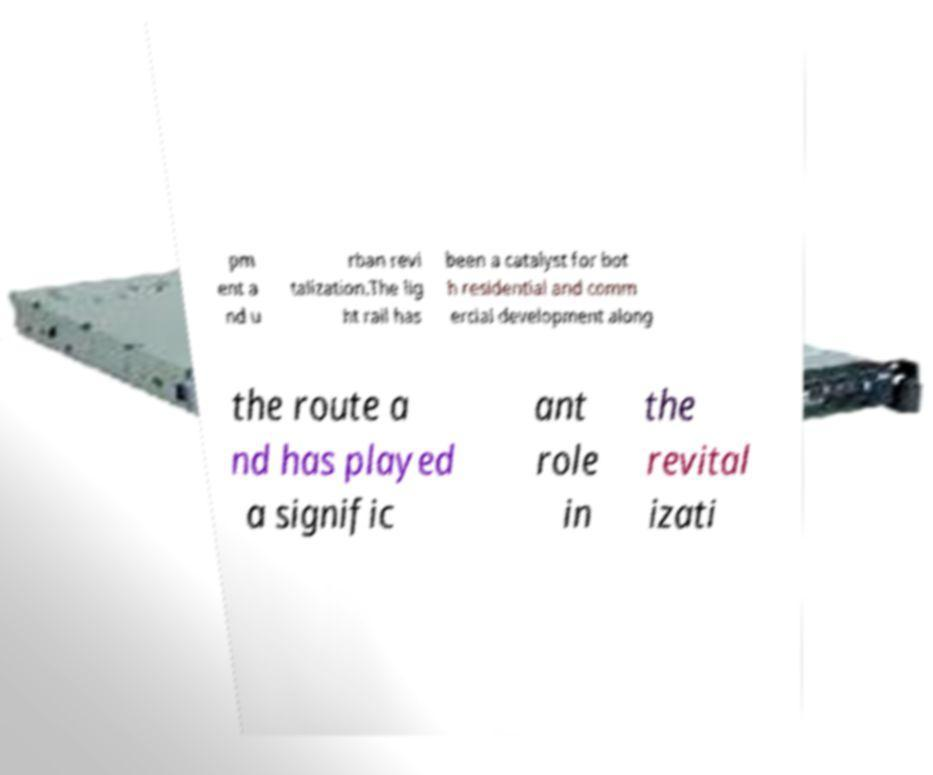For documentation purposes, I need the text within this image transcribed. Could you provide that? pm ent a nd u rban revi talization.The lig ht rail has been a catalyst for bot h residential and comm ercial development along the route a nd has played a signific ant role in the revital izati 